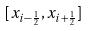<formula> <loc_0><loc_0><loc_500><loc_500>[ x _ { i - \frac { 1 } { 2 } } , x _ { i + \frac { 1 } { 2 } } ]</formula> 